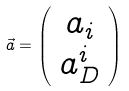<formula> <loc_0><loc_0><loc_500><loc_500>\vec { a } = \left ( \begin{array} { c } a _ { i } \\ a _ { D } ^ { i } \end{array} \right )</formula> 